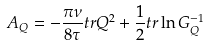<formula> <loc_0><loc_0><loc_500><loc_500>A _ { Q } = - \frac { \pi \nu } { 8 \tau } { t r } Q ^ { 2 } + \frac { 1 } { 2 } { t r } \ln G _ { Q } ^ { - 1 }</formula> 